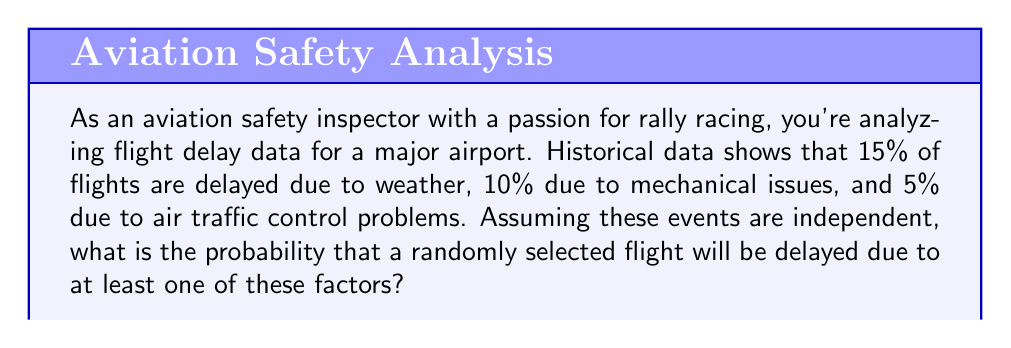What is the answer to this math problem? To solve this problem, we'll use the concept of probability of union of events and the complement rule. Let's approach this step-by-step:

1) Define the events:
   W: Flight delayed due to weather
   M: Flight delayed due to mechanical issues
   A: Flight delayed due to air traffic control

2) Given probabilities:
   $P(W) = 0.15$
   $P(M) = 0.10$
   $P(A) = 0.05$

3) We need to find $P(W \cup M \cup A)$, the probability of at least one of these events occurring.

4) Using the complement rule:
   $P(W \cup M \cup A) = 1 - P(\text{no delay})$

5) The probability of no delay is the complement of all three events occurring:
   $P(\text{no delay}) = P(W^c \cap M^c \cap A^c)$

6) Since the events are independent:
   $P(W^c \cap M^c \cap A^c) = P(W^c) \cdot P(M^c) \cdot P(A^c)$

7) Calculate the complements:
   $P(W^c) = 1 - P(W) = 1 - 0.15 = 0.85$
   $P(M^c) = 1 - P(M) = 1 - 0.10 = 0.90$
   $P(A^c) = 1 - P(A) = 1 - 0.05 = 0.95$

8) Now we can calculate:
   $P(\text{no delay}) = 0.85 \cdot 0.90 \cdot 0.95 = 0.72675$

9) Finally:
   $P(W \cup M \cup A) = 1 - P(\text{no delay}) = 1 - 0.72675 = 0.27325$

Therefore, the probability that a randomly selected flight will be delayed due to at least one of these factors is approximately 0.27325 or 27.325%.
Answer: The probability is approximately 0.27325 or 27.325%. 